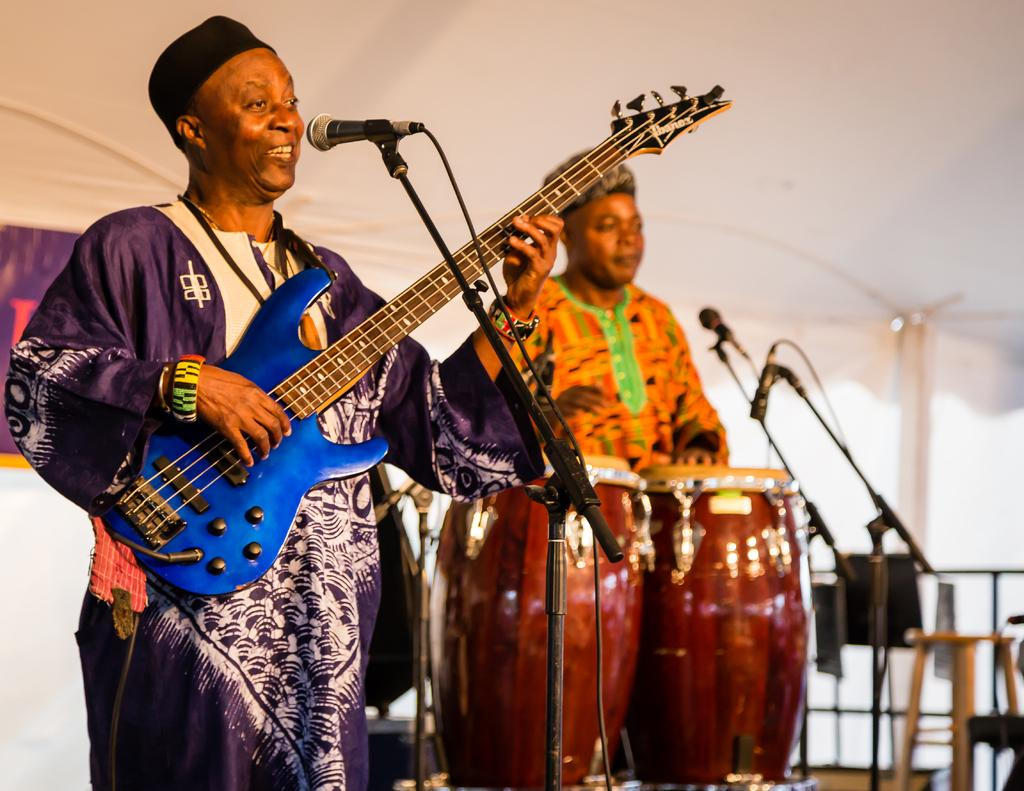How many people are in the image? There are two people in the image. What are the two people doing in the image? The two people are playing musical instruments. What type of prose can be heard being recited by the people in the image? There is no indication in the image that the people are reciting any prose, as they are playing musical instruments. 